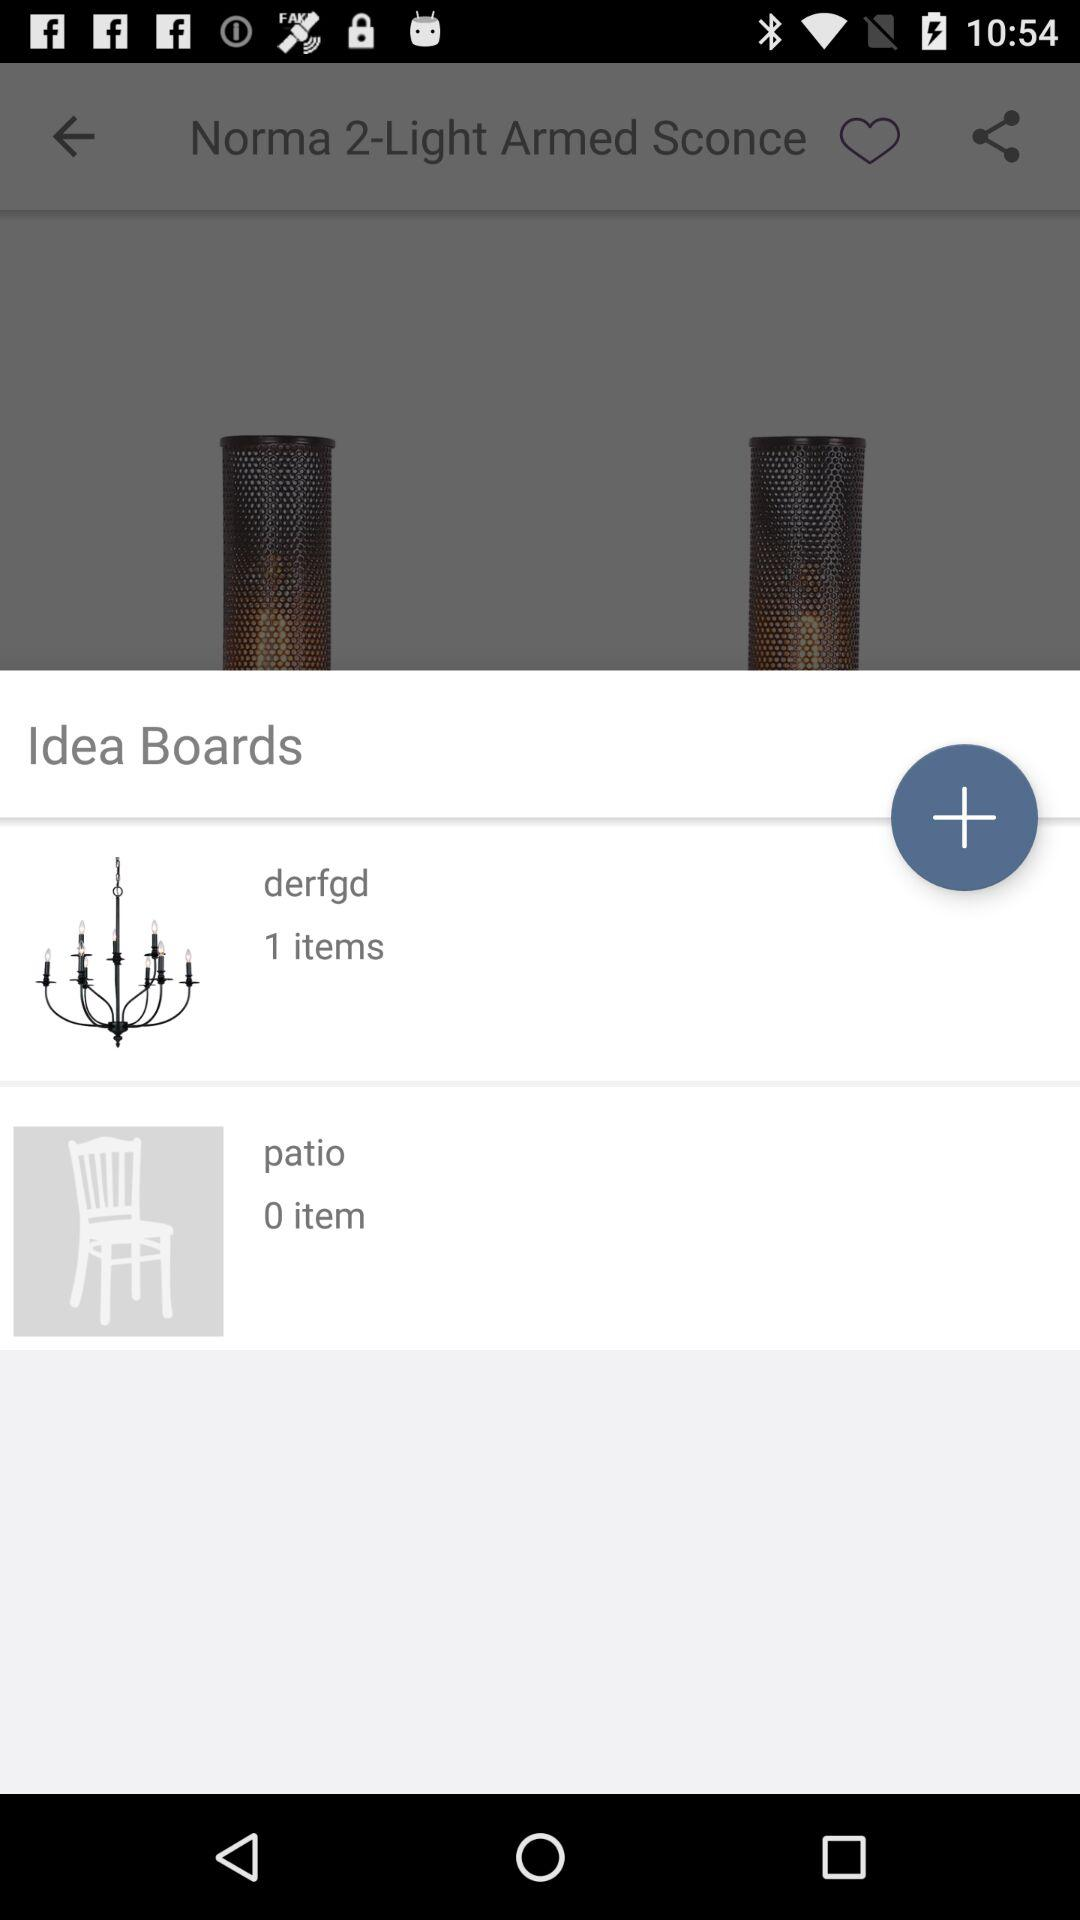How many item are in "derfgd"? There is 1 item in "derfgd". 